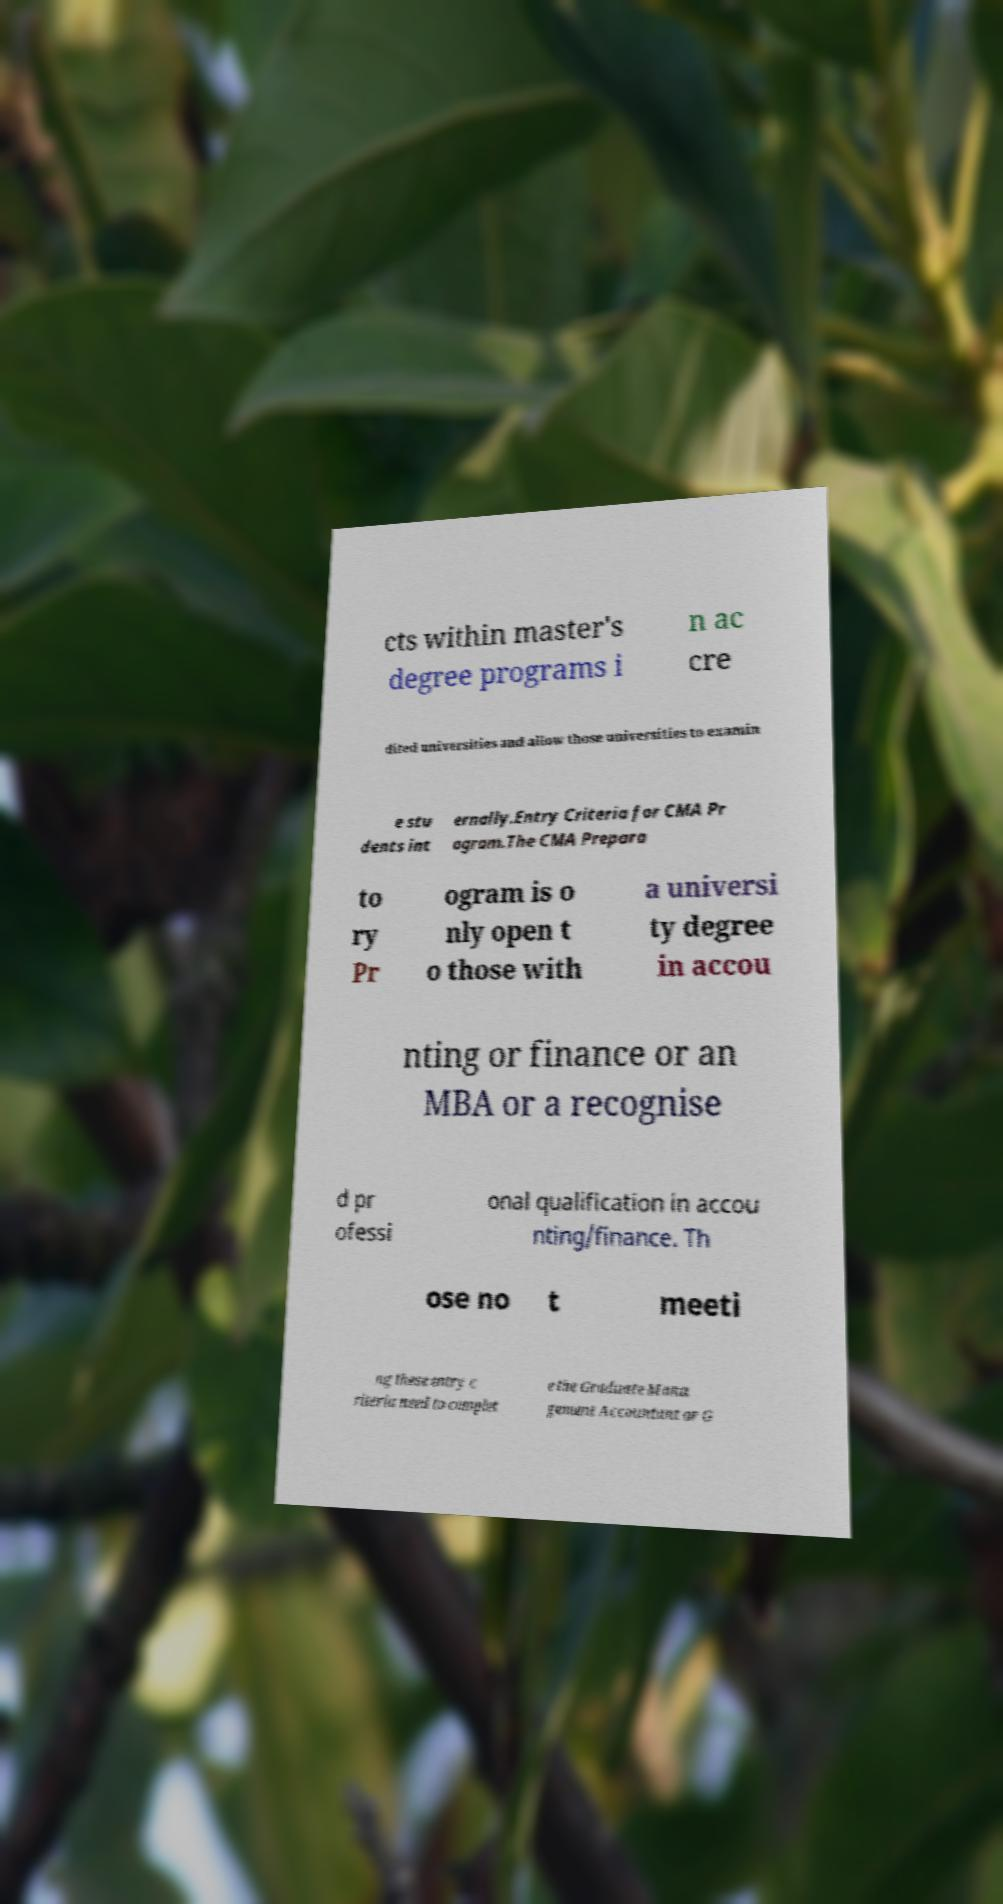What messages or text are displayed in this image? I need them in a readable, typed format. cts within master's degree programs i n ac cre dited universities and allow those universities to examin e stu dents int ernally.Entry Criteria for CMA Pr ogram.The CMA Prepara to ry Pr ogram is o nly open t o those with a universi ty degree in accou nting or finance or an MBA or a recognise d pr ofessi onal qualification in accou nting/finance. Th ose no t meeti ng these entry c riteria need to complet e the Graduate Mana gement Accountant or G 